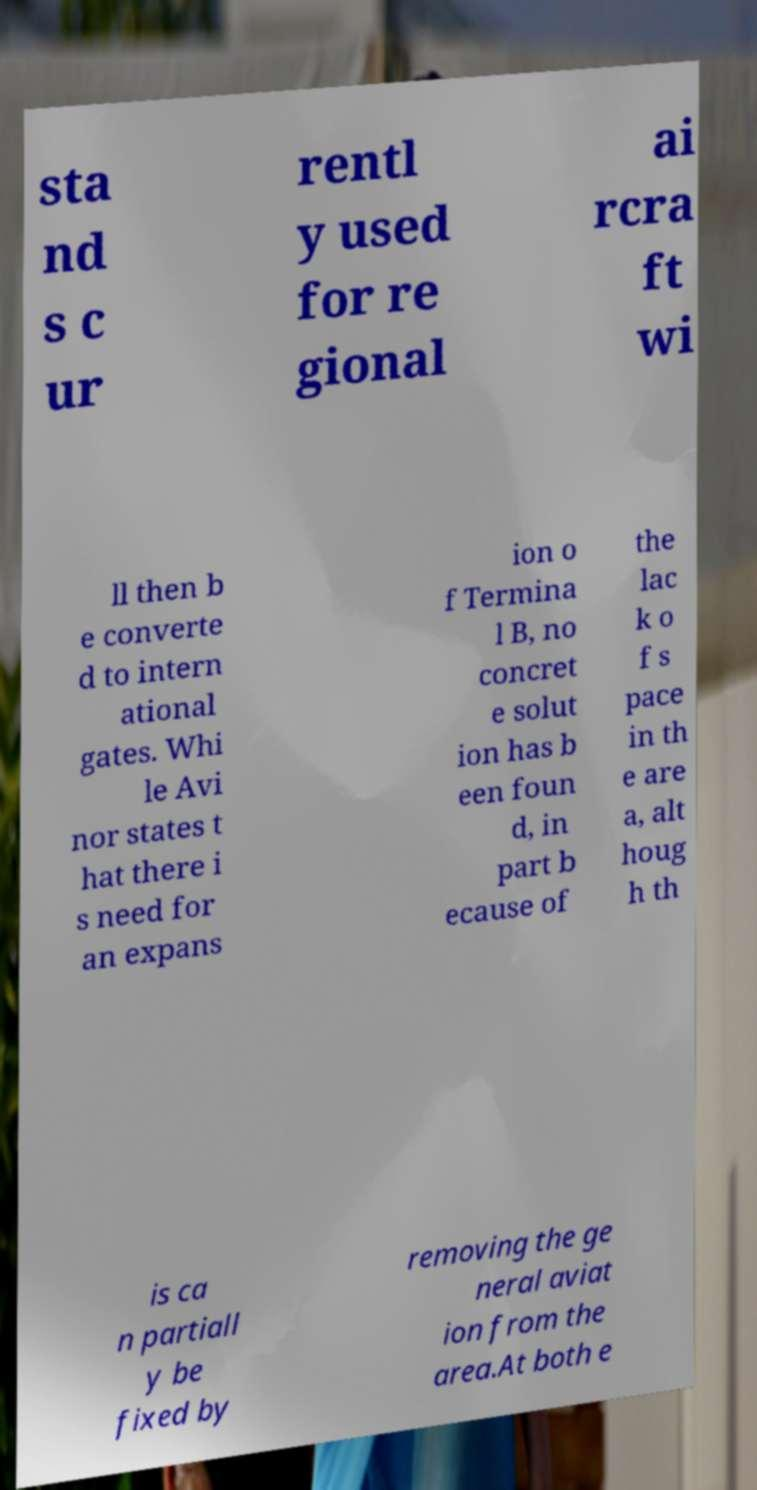I need the written content from this picture converted into text. Can you do that? sta nd s c ur rentl y used for re gional ai rcra ft wi ll then b e converte d to intern ational gates. Whi le Avi nor states t hat there i s need for an expans ion o f Termina l B, no concret e solut ion has b een foun d, in part b ecause of the lac k o f s pace in th e are a, alt houg h th is ca n partiall y be fixed by removing the ge neral aviat ion from the area.At both e 